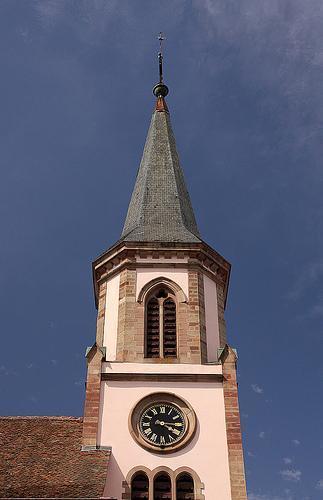How many clocks are there?
Give a very brief answer. 1. 